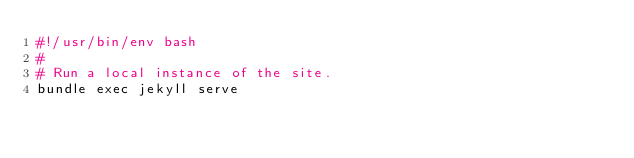<code> <loc_0><loc_0><loc_500><loc_500><_Bash_>#!/usr/bin/env bash
#
# Run a local instance of the site.
bundle exec jekyll serve
</code> 